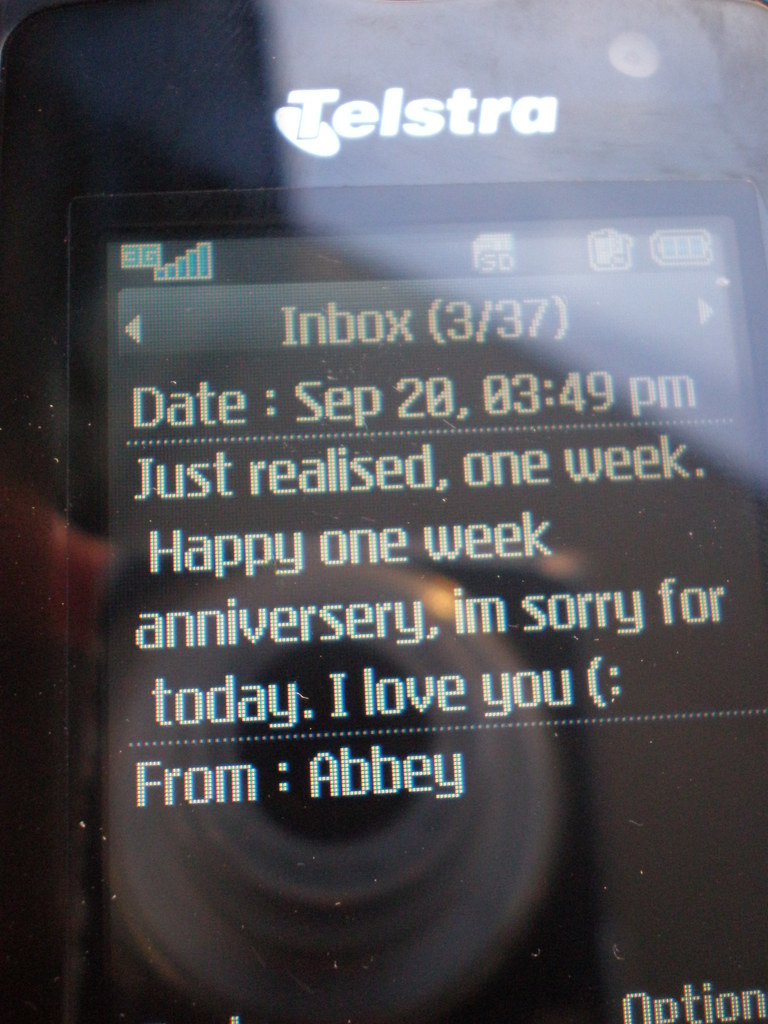Provide a one-sentence caption for the provided image. The image displays a heartfelt apology and anniversary message on a mobile phone, where 'Abbey' expresses remorse and affection, marking the significance of a one-week anniversary. 